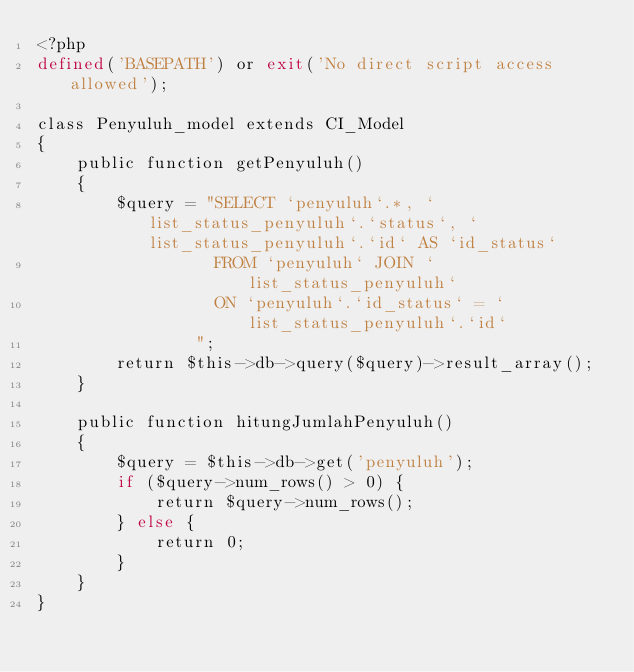<code> <loc_0><loc_0><loc_500><loc_500><_PHP_><?php
defined('BASEPATH') or exit('No direct script access allowed');

class Penyuluh_model extends CI_Model
{
    public function getPenyuluh()
    {
        $query = "SELECT `penyuluh`.*, `list_status_penyuluh`.`status`, `list_status_penyuluh`.`id` AS `id_status`
                  FROM `penyuluh` JOIN `list_status_penyuluh`
                  ON `penyuluh`.`id_status` = `list_status_penyuluh`.`id`
                ";
        return $this->db->query($query)->result_array();
    }

    public function hitungJumlahPenyuluh()
    {
        $query = $this->db->get('penyuluh');
        if ($query->num_rows() > 0) {
            return $query->num_rows();
        } else {
            return 0;
        }
    }
}
</code> 